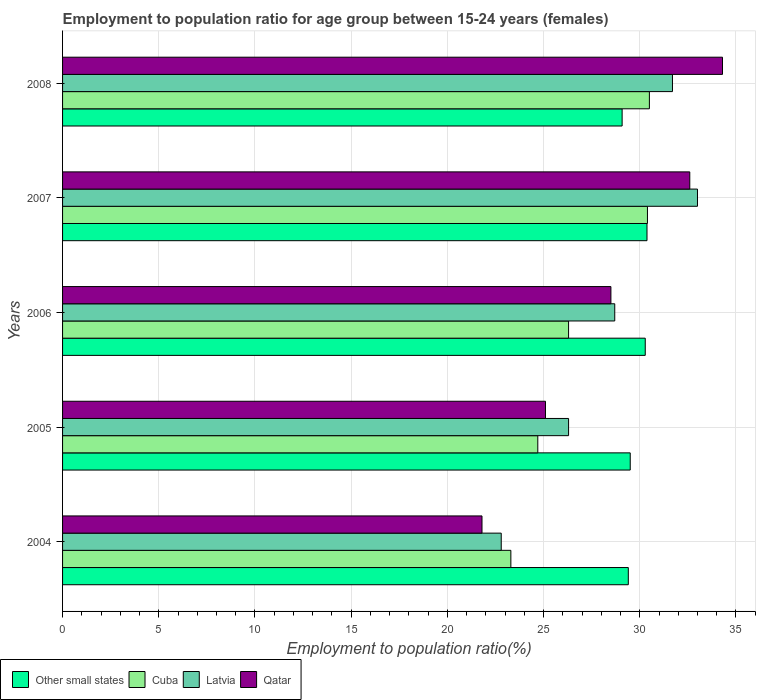How many different coloured bars are there?
Offer a terse response. 4. Are the number of bars per tick equal to the number of legend labels?
Provide a succinct answer. Yes. What is the label of the 5th group of bars from the top?
Keep it short and to the point. 2004. In how many cases, is the number of bars for a given year not equal to the number of legend labels?
Ensure brevity in your answer.  0. What is the employment to population ratio in Other small states in 2004?
Provide a short and direct response. 29.4. Across all years, what is the maximum employment to population ratio in Qatar?
Make the answer very short. 34.3. Across all years, what is the minimum employment to population ratio in Latvia?
Offer a terse response. 22.8. In which year was the employment to population ratio in Other small states minimum?
Ensure brevity in your answer.  2008. What is the total employment to population ratio in Other small states in the graph?
Provide a short and direct response. 148.65. What is the difference between the employment to population ratio in Qatar in 2005 and that in 2006?
Keep it short and to the point. -3.4. What is the difference between the employment to population ratio in Latvia in 2004 and the employment to population ratio in Other small states in 2007?
Provide a short and direct response. -7.58. What is the average employment to population ratio in Qatar per year?
Your response must be concise. 28.46. In the year 2004, what is the difference between the employment to population ratio in Qatar and employment to population ratio in Other small states?
Provide a short and direct response. -7.6. What is the ratio of the employment to population ratio in Other small states in 2004 to that in 2006?
Ensure brevity in your answer.  0.97. Is the difference between the employment to population ratio in Qatar in 2005 and 2006 greater than the difference between the employment to population ratio in Other small states in 2005 and 2006?
Provide a succinct answer. No. What is the difference between the highest and the second highest employment to population ratio in Other small states?
Your response must be concise. 0.09. What is the difference between the highest and the lowest employment to population ratio in Qatar?
Ensure brevity in your answer.  12.5. In how many years, is the employment to population ratio in Other small states greater than the average employment to population ratio in Other small states taken over all years?
Ensure brevity in your answer.  2. Is the sum of the employment to population ratio in Qatar in 2004 and 2006 greater than the maximum employment to population ratio in Cuba across all years?
Offer a very short reply. Yes. Is it the case that in every year, the sum of the employment to population ratio in Cuba and employment to population ratio in Other small states is greater than the sum of employment to population ratio in Latvia and employment to population ratio in Qatar?
Give a very brief answer. No. What does the 2nd bar from the top in 2005 represents?
Make the answer very short. Latvia. What does the 1st bar from the bottom in 2007 represents?
Keep it short and to the point. Other small states. Is it the case that in every year, the sum of the employment to population ratio in Latvia and employment to population ratio in Cuba is greater than the employment to population ratio in Qatar?
Ensure brevity in your answer.  Yes. How many years are there in the graph?
Give a very brief answer. 5. What is the difference between two consecutive major ticks on the X-axis?
Offer a very short reply. 5. How many legend labels are there?
Your answer should be very brief. 4. How are the legend labels stacked?
Provide a short and direct response. Horizontal. What is the title of the graph?
Your answer should be compact. Employment to population ratio for age group between 15-24 years (females). What is the label or title of the X-axis?
Make the answer very short. Employment to population ratio(%). What is the label or title of the Y-axis?
Keep it short and to the point. Years. What is the Employment to population ratio(%) of Other small states in 2004?
Give a very brief answer. 29.4. What is the Employment to population ratio(%) of Cuba in 2004?
Make the answer very short. 23.3. What is the Employment to population ratio(%) in Latvia in 2004?
Your answer should be compact. 22.8. What is the Employment to population ratio(%) of Qatar in 2004?
Provide a short and direct response. 21.8. What is the Employment to population ratio(%) in Other small states in 2005?
Provide a succinct answer. 29.5. What is the Employment to population ratio(%) in Cuba in 2005?
Provide a short and direct response. 24.7. What is the Employment to population ratio(%) in Latvia in 2005?
Give a very brief answer. 26.3. What is the Employment to population ratio(%) of Qatar in 2005?
Your answer should be compact. 25.1. What is the Employment to population ratio(%) in Other small states in 2006?
Offer a terse response. 30.28. What is the Employment to population ratio(%) in Cuba in 2006?
Give a very brief answer. 26.3. What is the Employment to population ratio(%) in Latvia in 2006?
Your answer should be compact. 28.7. What is the Employment to population ratio(%) of Other small states in 2007?
Ensure brevity in your answer.  30.38. What is the Employment to population ratio(%) of Cuba in 2007?
Your response must be concise. 30.4. What is the Employment to population ratio(%) of Latvia in 2007?
Give a very brief answer. 33. What is the Employment to population ratio(%) of Qatar in 2007?
Provide a short and direct response. 32.6. What is the Employment to population ratio(%) of Other small states in 2008?
Offer a terse response. 29.08. What is the Employment to population ratio(%) in Cuba in 2008?
Offer a terse response. 30.5. What is the Employment to population ratio(%) of Latvia in 2008?
Offer a terse response. 31.7. What is the Employment to population ratio(%) in Qatar in 2008?
Make the answer very short. 34.3. Across all years, what is the maximum Employment to population ratio(%) in Other small states?
Your answer should be compact. 30.38. Across all years, what is the maximum Employment to population ratio(%) in Cuba?
Give a very brief answer. 30.5. Across all years, what is the maximum Employment to population ratio(%) of Latvia?
Your response must be concise. 33. Across all years, what is the maximum Employment to population ratio(%) in Qatar?
Provide a short and direct response. 34.3. Across all years, what is the minimum Employment to population ratio(%) of Other small states?
Your response must be concise. 29.08. Across all years, what is the minimum Employment to population ratio(%) in Cuba?
Keep it short and to the point. 23.3. Across all years, what is the minimum Employment to population ratio(%) of Latvia?
Provide a succinct answer. 22.8. Across all years, what is the minimum Employment to population ratio(%) in Qatar?
Make the answer very short. 21.8. What is the total Employment to population ratio(%) of Other small states in the graph?
Provide a short and direct response. 148.65. What is the total Employment to population ratio(%) of Cuba in the graph?
Offer a terse response. 135.2. What is the total Employment to population ratio(%) in Latvia in the graph?
Offer a terse response. 142.5. What is the total Employment to population ratio(%) in Qatar in the graph?
Offer a terse response. 142.3. What is the difference between the Employment to population ratio(%) of Other small states in 2004 and that in 2005?
Your answer should be compact. -0.1. What is the difference between the Employment to population ratio(%) of Cuba in 2004 and that in 2005?
Offer a terse response. -1.4. What is the difference between the Employment to population ratio(%) of Latvia in 2004 and that in 2005?
Provide a short and direct response. -3.5. What is the difference between the Employment to population ratio(%) of Qatar in 2004 and that in 2005?
Offer a very short reply. -3.3. What is the difference between the Employment to population ratio(%) in Other small states in 2004 and that in 2006?
Offer a very short reply. -0.88. What is the difference between the Employment to population ratio(%) of Latvia in 2004 and that in 2006?
Ensure brevity in your answer.  -5.9. What is the difference between the Employment to population ratio(%) in Other small states in 2004 and that in 2007?
Keep it short and to the point. -0.97. What is the difference between the Employment to population ratio(%) in Latvia in 2004 and that in 2007?
Keep it short and to the point. -10.2. What is the difference between the Employment to population ratio(%) of Qatar in 2004 and that in 2007?
Offer a very short reply. -10.8. What is the difference between the Employment to population ratio(%) of Other small states in 2004 and that in 2008?
Make the answer very short. 0.32. What is the difference between the Employment to population ratio(%) in Other small states in 2005 and that in 2006?
Ensure brevity in your answer.  -0.78. What is the difference between the Employment to population ratio(%) in Latvia in 2005 and that in 2006?
Offer a terse response. -2.4. What is the difference between the Employment to population ratio(%) in Other small states in 2005 and that in 2007?
Your response must be concise. -0.87. What is the difference between the Employment to population ratio(%) in Other small states in 2005 and that in 2008?
Ensure brevity in your answer.  0.42. What is the difference between the Employment to population ratio(%) in Other small states in 2006 and that in 2007?
Offer a very short reply. -0.09. What is the difference between the Employment to population ratio(%) in Other small states in 2006 and that in 2008?
Make the answer very short. 1.2. What is the difference between the Employment to population ratio(%) in Qatar in 2006 and that in 2008?
Your answer should be very brief. -5.8. What is the difference between the Employment to population ratio(%) of Other small states in 2007 and that in 2008?
Your answer should be compact. 1.29. What is the difference between the Employment to population ratio(%) in Cuba in 2007 and that in 2008?
Offer a terse response. -0.1. What is the difference between the Employment to population ratio(%) of Latvia in 2007 and that in 2008?
Provide a succinct answer. 1.3. What is the difference between the Employment to population ratio(%) of Other small states in 2004 and the Employment to population ratio(%) of Cuba in 2005?
Ensure brevity in your answer.  4.7. What is the difference between the Employment to population ratio(%) in Other small states in 2004 and the Employment to population ratio(%) in Latvia in 2005?
Provide a succinct answer. 3.1. What is the difference between the Employment to population ratio(%) of Other small states in 2004 and the Employment to population ratio(%) of Qatar in 2005?
Provide a succinct answer. 4.3. What is the difference between the Employment to population ratio(%) in Other small states in 2004 and the Employment to population ratio(%) in Cuba in 2006?
Ensure brevity in your answer.  3.1. What is the difference between the Employment to population ratio(%) in Other small states in 2004 and the Employment to population ratio(%) in Latvia in 2006?
Provide a succinct answer. 0.7. What is the difference between the Employment to population ratio(%) in Other small states in 2004 and the Employment to population ratio(%) in Qatar in 2006?
Give a very brief answer. 0.9. What is the difference between the Employment to population ratio(%) in Cuba in 2004 and the Employment to population ratio(%) in Latvia in 2006?
Provide a short and direct response. -5.4. What is the difference between the Employment to population ratio(%) of Cuba in 2004 and the Employment to population ratio(%) of Qatar in 2006?
Ensure brevity in your answer.  -5.2. What is the difference between the Employment to population ratio(%) in Other small states in 2004 and the Employment to population ratio(%) in Cuba in 2007?
Provide a short and direct response. -1. What is the difference between the Employment to population ratio(%) in Other small states in 2004 and the Employment to population ratio(%) in Latvia in 2007?
Give a very brief answer. -3.6. What is the difference between the Employment to population ratio(%) of Other small states in 2004 and the Employment to population ratio(%) of Qatar in 2007?
Your answer should be very brief. -3.2. What is the difference between the Employment to population ratio(%) in Cuba in 2004 and the Employment to population ratio(%) in Qatar in 2007?
Give a very brief answer. -9.3. What is the difference between the Employment to population ratio(%) of Other small states in 2004 and the Employment to population ratio(%) of Cuba in 2008?
Offer a terse response. -1.1. What is the difference between the Employment to population ratio(%) in Other small states in 2004 and the Employment to population ratio(%) in Latvia in 2008?
Your answer should be very brief. -2.3. What is the difference between the Employment to population ratio(%) in Other small states in 2004 and the Employment to population ratio(%) in Qatar in 2008?
Your answer should be very brief. -4.9. What is the difference between the Employment to population ratio(%) in Cuba in 2004 and the Employment to population ratio(%) in Qatar in 2008?
Provide a succinct answer. -11. What is the difference between the Employment to population ratio(%) of Other small states in 2005 and the Employment to population ratio(%) of Cuba in 2006?
Give a very brief answer. 3.2. What is the difference between the Employment to population ratio(%) in Other small states in 2005 and the Employment to population ratio(%) in Latvia in 2006?
Offer a terse response. 0.8. What is the difference between the Employment to population ratio(%) of Cuba in 2005 and the Employment to population ratio(%) of Latvia in 2006?
Offer a terse response. -4. What is the difference between the Employment to population ratio(%) of Cuba in 2005 and the Employment to population ratio(%) of Qatar in 2006?
Your answer should be very brief. -3.8. What is the difference between the Employment to population ratio(%) in Other small states in 2005 and the Employment to population ratio(%) in Cuba in 2007?
Your response must be concise. -0.9. What is the difference between the Employment to population ratio(%) of Other small states in 2005 and the Employment to population ratio(%) of Latvia in 2007?
Give a very brief answer. -3.5. What is the difference between the Employment to population ratio(%) of Other small states in 2005 and the Employment to population ratio(%) of Qatar in 2007?
Provide a succinct answer. -3.1. What is the difference between the Employment to population ratio(%) of Cuba in 2005 and the Employment to population ratio(%) of Latvia in 2007?
Your answer should be compact. -8.3. What is the difference between the Employment to population ratio(%) of Other small states in 2005 and the Employment to population ratio(%) of Cuba in 2008?
Offer a terse response. -1. What is the difference between the Employment to population ratio(%) in Other small states in 2005 and the Employment to population ratio(%) in Latvia in 2008?
Your answer should be compact. -2.2. What is the difference between the Employment to population ratio(%) in Other small states in 2005 and the Employment to population ratio(%) in Qatar in 2008?
Your response must be concise. -4.8. What is the difference between the Employment to population ratio(%) in Cuba in 2005 and the Employment to population ratio(%) in Latvia in 2008?
Ensure brevity in your answer.  -7. What is the difference between the Employment to population ratio(%) of Other small states in 2006 and the Employment to population ratio(%) of Cuba in 2007?
Keep it short and to the point. -0.12. What is the difference between the Employment to population ratio(%) in Other small states in 2006 and the Employment to population ratio(%) in Latvia in 2007?
Offer a very short reply. -2.72. What is the difference between the Employment to population ratio(%) of Other small states in 2006 and the Employment to population ratio(%) of Qatar in 2007?
Offer a terse response. -2.32. What is the difference between the Employment to population ratio(%) in Cuba in 2006 and the Employment to population ratio(%) in Latvia in 2007?
Your answer should be compact. -6.7. What is the difference between the Employment to population ratio(%) in Latvia in 2006 and the Employment to population ratio(%) in Qatar in 2007?
Provide a succinct answer. -3.9. What is the difference between the Employment to population ratio(%) of Other small states in 2006 and the Employment to population ratio(%) of Cuba in 2008?
Your answer should be very brief. -0.22. What is the difference between the Employment to population ratio(%) in Other small states in 2006 and the Employment to population ratio(%) in Latvia in 2008?
Offer a terse response. -1.42. What is the difference between the Employment to population ratio(%) in Other small states in 2006 and the Employment to population ratio(%) in Qatar in 2008?
Provide a succinct answer. -4.02. What is the difference between the Employment to population ratio(%) in Cuba in 2006 and the Employment to population ratio(%) in Latvia in 2008?
Ensure brevity in your answer.  -5.4. What is the difference between the Employment to population ratio(%) of Cuba in 2006 and the Employment to population ratio(%) of Qatar in 2008?
Give a very brief answer. -8. What is the difference between the Employment to population ratio(%) in Other small states in 2007 and the Employment to population ratio(%) in Cuba in 2008?
Provide a succinct answer. -0.12. What is the difference between the Employment to population ratio(%) of Other small states in 2007 and the Employment to population ratio(%) of Latvia in 2008?
Offer a terse response. -1.32. What is the difference between the Employment to population ratio(%) in Other small states in 2007 and the Employment to population ratio(%) in Qatar in 2008?
Give a very brief answer. -3.92. What is the difference between the Employment to population ratio(%) in Latvia in 2007 and the Employment to population ratio(%) in Qatar in 2008?
Provide a short and direct response. -1.3. What is the average Employment to population ratio(%) of Other small states per year?
Make the answer very short. 29.73. What is the average Employment to population ratio(%) in Cuba per year?
Your response must be concise. 27.04. What is the average Employment to population ratio(%) in Latvia per year?
Give a very brief answer. 28.5. What is the average Employment to population ratio(%) in Qatar per year?
Give a very brief answer. 28.46. In the year 2004, what is the difference between the Employment to population ratio(%) of Other small states and Employment to population ratio(%) of Cuba?
Give a very brief answer. 6.1. In the year 2004, what is the difference between the Employment to population ratio(%) of Other small states and Employment to population ratio(%) of Latvia?
Offer a very short reply. 6.6. In the year 2004, what is the difference between the Employment to population ratio(%) in Other small states and Employment to population ratio(%) in Qatar?
Make the answer very short. 7.6. In the year 2004, what is the difference between the Employment to population ratio(%) in Cuba and Employment to population ratio(%) in Latvia?
Your response must be concise. 0.5. In the year 2004, what is the difference between the Employment to population ratio(%) in Cuba and Employment to population ratio(%) in Qatar?
Offer a terse response. 1.5. In the year 2005, what is the difference between the Employment to population ratio(%) of Other small states and Employment to population ratio(%) of Cuba?
Your answer should be very brief. 4.8. In the year 2005, what is the difference between the Employment to population ratio(%) of Other small states and Employment to population ratio(%) of Latvia?
Your response must be concise. 3.2. In the year 2005, what is the difference between the Employment to population ratio(%) of Other small states and Employment to population ratio(%) of Qatar?
Your answer should be very brief. 4.4. In the year 2005, what is the difference between the Employment to population ratio(%) in Cuba and Employment to population ratio(%) in Latvia?
Your response must be concise. -1.6. In the year 2005, what is the difference between the Employment to population ratio(%) of Cuba and Employment to population ratio(%) of Qatar?
Make the answer very short. -0.4. In the year 2006, what is the difference between the Employment to population ratio(%) of Other small states and Employment to population ratio(%) of Cuba?
Offer a very short reply. 3.98. In the year 2006, what is the difference between the Employment to population ratio(%) in Other small states and Employment to population ratio(%) in Latvia?
Keep it short and to the point. 1.58. In the year 2006, what is the difference between the Employment to population ratio(%) of Other small states and Employment to population ratio(%) of Qatar?
Provide a short and direct response. 1.78. In the year 2006, what is the difference between the Employment to population ratio(%) in Latvia and Employment to population ratio(%) in Qatar?
Ensure brevity in your answer.  0.2. In the year 2007, what is the difference between the Employment to population ratio(%) in Other small states and Employment to population ratio(%) in Cuba?
Offer a terse response. -0.02. In the year 2007, what is the difference between the Employment to population ratio(%) of Other small states and Employment to population ratio(%) of Latvia?
Your answer should be compact. -2.62. In the year 2007, what is the difference between the Employment to population ratio(%) of Other small states and Employment to population ratio(%) of Qatar?
Keep it short and to the point. -2.22. In the year 2007, what is the difference between the Employment to population ratio(%) in Cuba and Employment to population ratio(%) in Latvia?
Your answer should be very brief. -2.6. In the year 2007, what is the difference between the Employment to population ratio(%) of Cuba and Employment to population ratio(%) of Qatar?
Ensure brevity in your answer.  -2.2. In the year 2007, what is the difference between the Employment to population ratio(%) in Latvia and Employment to population ratio(%) in Qatar?
Offer a very short reply. 0.4. In the year 2008, what is the difference between the Employment to population ratio(%) in Other small states and Employment to population ratio(%) in Cuba?
Provide a short and direct response. -1.42. In the year 2008, what is the difference between the Employment to population ratio(%) of Other small states and Employment to population ratio(%) of Latvia?
Offer a very short reply. -2.62. In the year 2008, what is the difference between the Employment to population ratio(%) of Other small states and Employment to population ratio(%) of Qatar?
Your response must be concise. -5.22. In the year 2008, what is the difference between the Employment to population ratio(%) in Cuba and Employment to population ratio(%) in Qatar?
Make the answer very short. -3.8. What is the ratio of the Employment to population ratio(%) in Other small states in 2004 to that in 2005?
Keep it short and to the point. 1. What is the ratio of the Employment to population ratio(%) in Cuba in 2004 to that in 2005?
Keep it short and to the point. 0.94. What is the ratio of the Employment to population ratio(%) of Latvia in 2004 to that in 2005?
Keep it short and to the point. 0.87. What is the ratio of the Employment to population ratio(%) of Qatar in 2004 to that in 2005?
Offer a very short reply. 0.87. What is the ratio of the Employment to population ratio(%) of Other small states in 2004 to that in 2006?
Your answer should be very brief. 0.97. What is the ratio of the Employment to population ratio(%) in Cuba in 2004 to that in 2006?
Ensure brevity in your answer.  0.89. What is the ratio of the Employment to population ratio(%) in Latvia in 2004 to that in 2006?
Ensure brevity in your answer.  0.79. What is the ratio of the Employment to population ratio(%) in Qatar in 2004 to that in 2006?
Provide a succinct answer. 0.76. What is the ratio of the Employment to population ratio(%) of Cuba in 2004 to that in 2007?
Ensure brevity in your answer.  0.77. What is the ratio of the Employment to population ratio(%) of Latvia in 2004 to that in 2007?
Your answer should be compact. 0.69. What is the ratio of the Employment to population ratio(%) of Qatar in 2004 to that in 2007?
Your answer should be very brief. 0.67. What is the ratio of the Employment to population ratio(%) of Cuba in 2004 to that in 2008?
Ensure brevity in your answer.  0.76. What is the ratio of the Employment to population ratio(%) of Latvia in 2004 to that in 2008?
Provide a short and direct response. 0.72. What is the ratio of the Employment to population ratio(%) of Qatar in 2004 to that in 2008?
Offer a very short reply. 0.64. What is the ratio of the Employment to population ratio(%) in Other small states in 2005 to that in 2006?
Provide a short and direct response. 0.97. What is the ratio of the Employment to population ratio(%) of Cuba in 2005 to that in 2006?
Provide a short and direct response. 0.94. What is the ratio of the Employment to population ratio(%) in Latvia in 2005 to that in 2006?
Your answer should be compact. 0.92. What is the ratio of the Employment to population ratio(%) in Qatar in 2005 to that in 2006?
Ensure brevity in your answer.  0.88. What is the ratio of the Employment to population ratio(%) in Other small states in 2005 to that in 2007?
Offer a very short reply. 0.97. What is the ratio of the Employment to population ratio(%) of Cuba in 2005 to that in 2007?
Make the answer very short. 0.81. What is the ratio of the Employment to population ratio(%) of Latvia in 2005 to that in 2007?
Keep it short and to the point. 0.8. What is the ratio of the Employment to population ratio(%) of Qatar in 2005 to that in 2007?
Provide a succinct answer. 0.77. What is the ratio of the Employment to population ratio(%) in Other small states in 2005 to that in 2008?
Ensure brevity in your answer.  1.01. What is the ratio of the Employment to population ratio(%) in Cuba in 2005 to that in 2008?
Your response must be concise. 0.81. What is the ratio of the Employment to population ratio(%) in Latvia in 2005 to that in 2008?
Offer a very short reply. 0.83. What is the ratio of the Employment to population ratio(%) of Qatar in 2005 to that in 2008?
Give a very brief answer. 0.73. What is the ratio of the Employment to population ratio(%) in Cuba in 2006 to that in 2007?
Give a very brief answer. 0.87. What is the ratio of the Employment to population ratio(%) of Latvia in 2006 to that in 2007?
Provide a succinct answer. 0.87. What is the ratio of the Employment to population ratio(%) of Qatar in 2006 to that in 2007?
Ensure brevity in your answer.  0.87. What is the ratio of the Employment to population ratio(%) of Other small states in 2006 to that in 2008?
Make the answer very short. 1.04. What is the ratio of the Employment to population ratio(%) of Cuba in 2006 to that in 2008?
Give a very brief answer. 0.86. What is the ratio of the Employment to population ratio(%) of Latvia in 2006 to that in 2008?
Offer a very short reply. 0.91. What is the ratio of the Employment to population ratio(%) in Qatar in 2006 to that in 2008?
Ensure brevity in your answer.  0.83. What is the ratio of the Employment to population ratio(%) in Other small states in 2007 to that in 2008?
Give a very brief answer. 1.04. What is the ratio of the Employment to population ratio(%) in Latvia in 2007 to that in 2008?
Offer a terse response. 1.04. What is the ratio of the Employment to population ratio(%) of Qatar in 2007 to that in 2008?
Give a very brief answer. 0.95. What is the difference between the highest and the second highest Employment to population ratio(%) of Other small states?
Give a very brief answer. 0.09. What is the difference between the highest and the second highest Employment to population ratio(%) in Cuba?
Provide a succinct answer. 0.1. What is the difference between the highest and the second highest Employment to population ratio(%) of Latvia?
Give a very brief answer. 1.3. What is the difference between the highest and the second highest Employment to population ratio(%) in Qatar?
Provide a short and direct response. 1.7. What is the difference between the highest and the lowest Employment to population ratio(%) in Other small states?
Your response must be concise. 1.29. What is the difference between the highest and the lowest Employment to population ratio(%) of Cuba?
Your answer should be very brief. 7.2. 